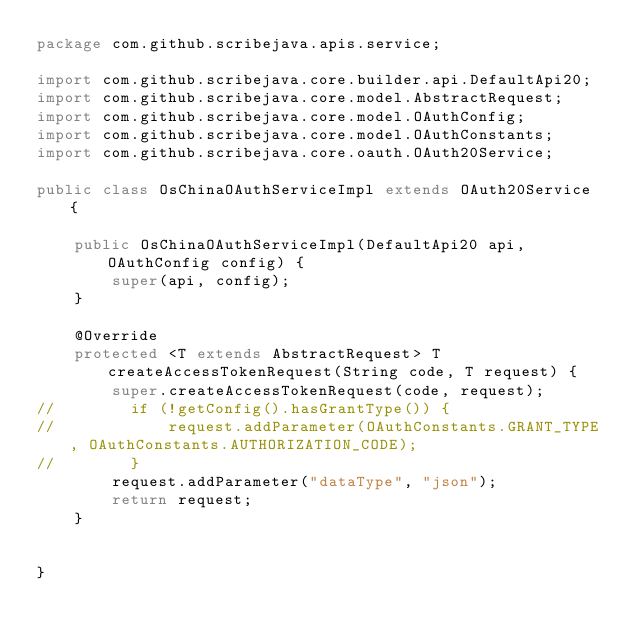<code> <loc_0><loc_0><loc_500><loc_500><_Java_>package com.github.scribejava.apis.service;

import com.github.scribejava.core.builder.api.DefaultApi20;
import com.github.scribejava.core.model.AbstractRequest;
import com.github.scribejava.core.model.OAuthConfig;
import com.github.scribejava.core.model.OAuthConstants;
import com.github.scribejava.core.oauth.OAuth20Service;

public class OsChinaOAuthServiceImpl extends OAuth20Service {

    public OsChinaOAuthServiceImpl(DefaultApi20 api, OAuthConfig config) {
        super(api, config);
    }

    @Override
    protected <T extends AbstractRequest> T createAccessTokenRequest(String code, T request) {
        super.createAccessTokenRequest(code, request);
//        if (!getConfig().hasGrantType()) {
//            request.addParameter(OAuthConstants.GRANT_TYPE, OAuthConstants.AUTHORIZATION_CODE);
//        }
        request.addParameter("dataType", "json");
        return request;
    }
    
   
}
</code> 